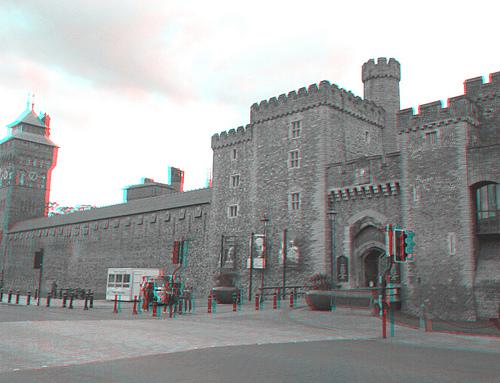Question: what type of entry way is on the building?
Choices:
A. Arch.
B. Covered.
C. Guarded.
D. Stone.
Answer with the letter. Answer: A Question: what is on the side of the left-most tower?
Choices:
A. Windows.
B. Lights.
C. Ivy.
D. Clocks.
Answer with the letter. Answer: D Question: what type of building does it appear to be?
Choices:
A. A castle.
B. Government.
C. Bank.
D. Church.
Answer with the letter. Answer: A 